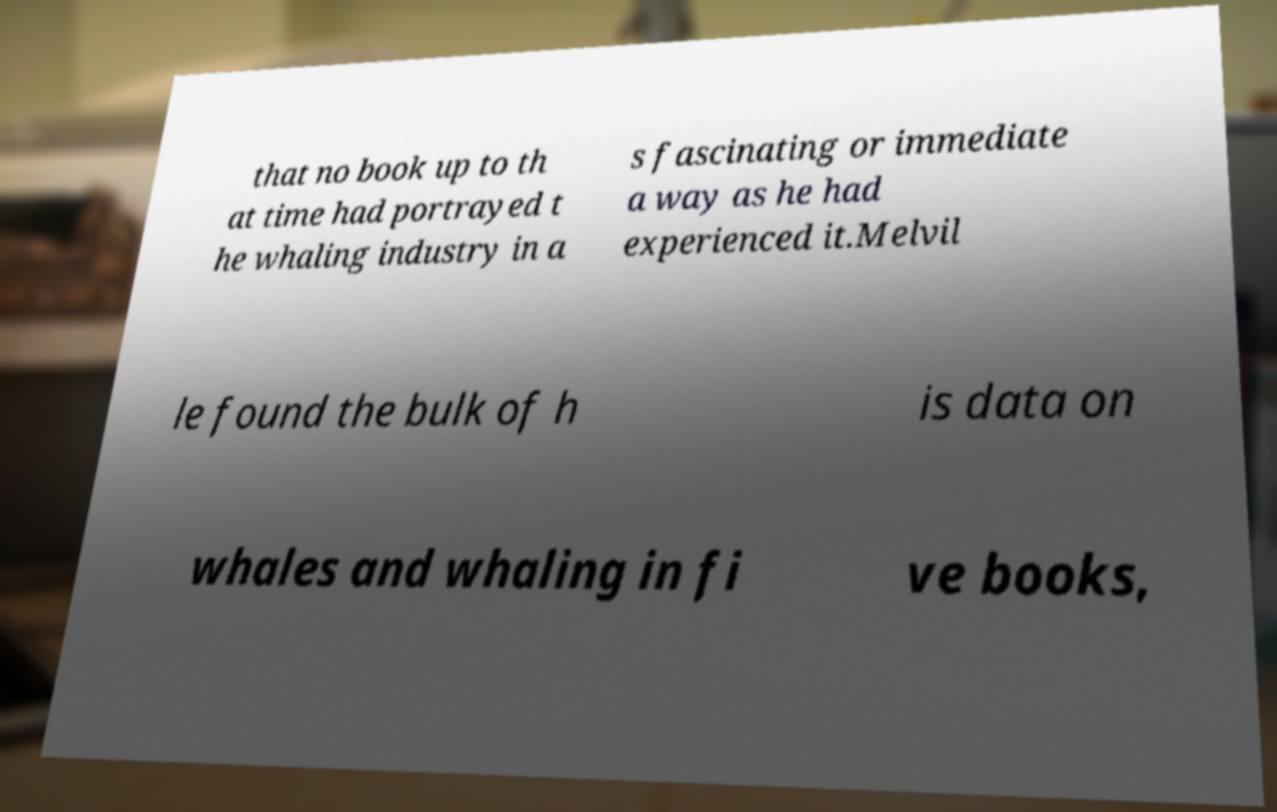For documentation purposes, I need the text within this image transcribed. Could you provide that? that no book up to th at time had portrayed t he whaling industry in a s fascinating or immediate a way as he had experienced it.Melvil le found the bulk of h is data on whales and whaling in fi ve books, 